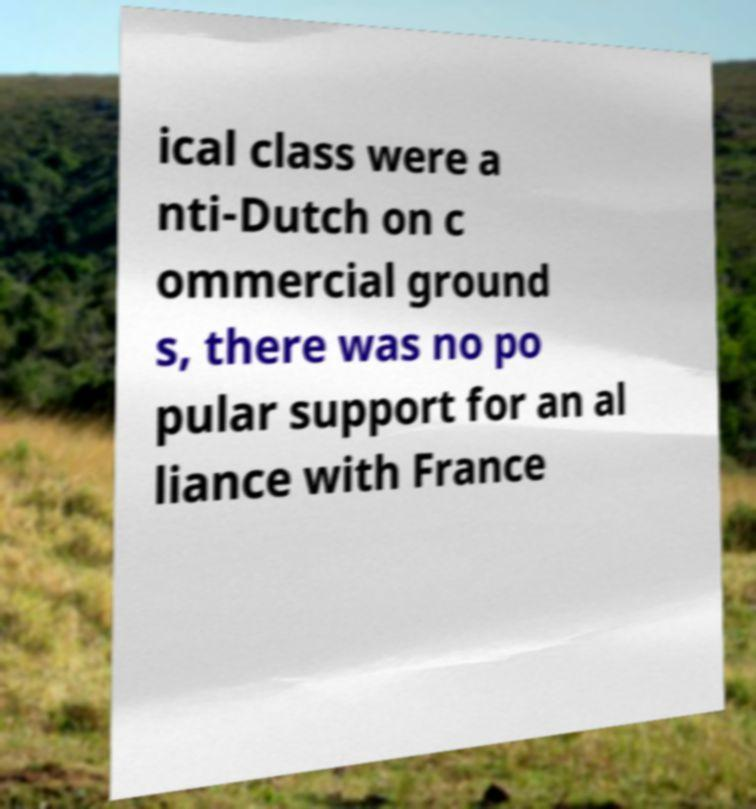Can you read and provide the text displayed in the image?This photo seems to have some interesting text. Can you extract and type it out for me? ical class were a nti-Dutch on c ommercial ground s, there was no po pular support for an al liance with France 